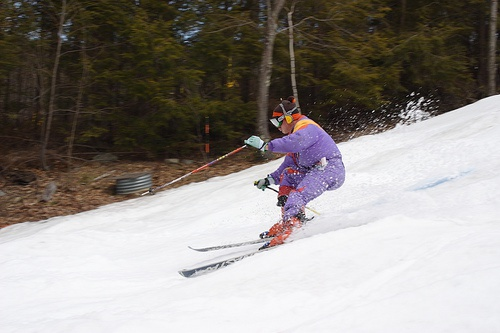Describe the objects in this image and their specific colors. I can see people in black, purple, violet, and darkgray tones and skis in black, lightgray, darkgray, and gray tones in this image. 